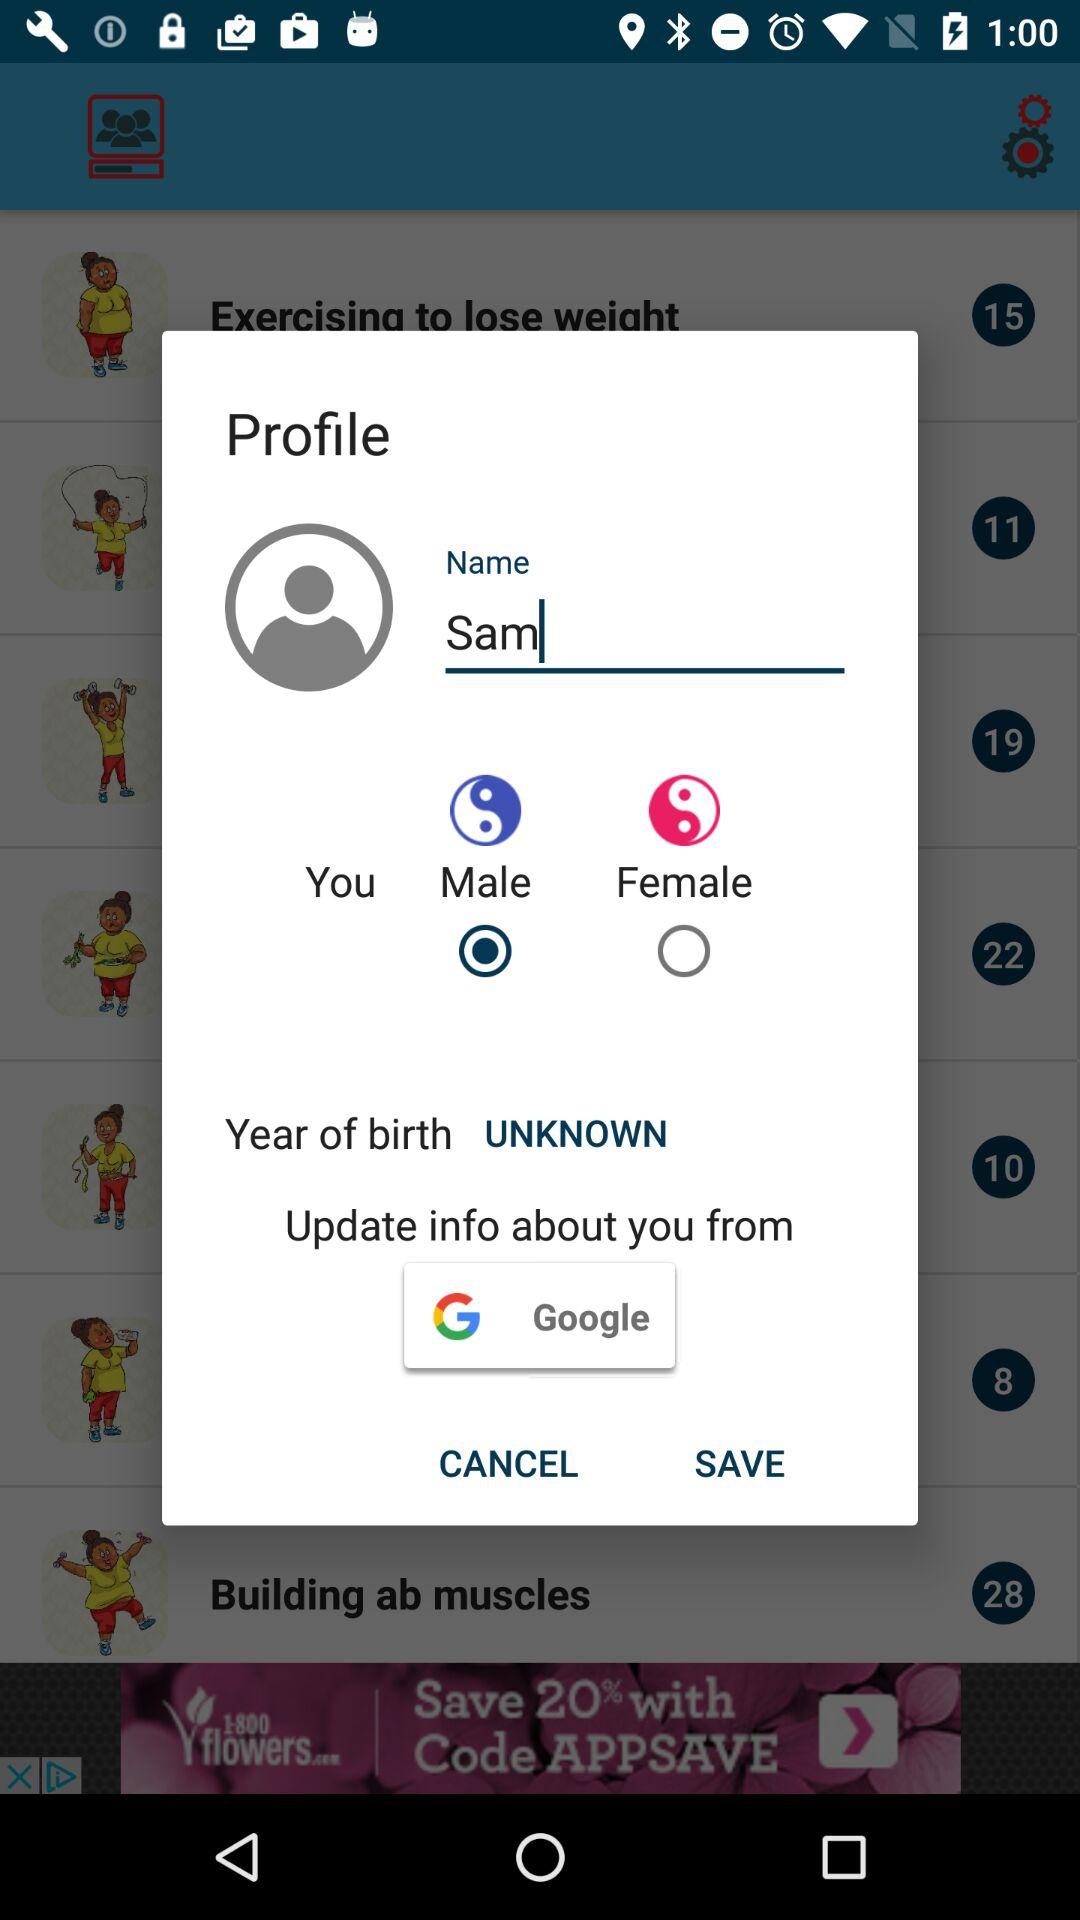What is the selected gender? The gender is "Male". 